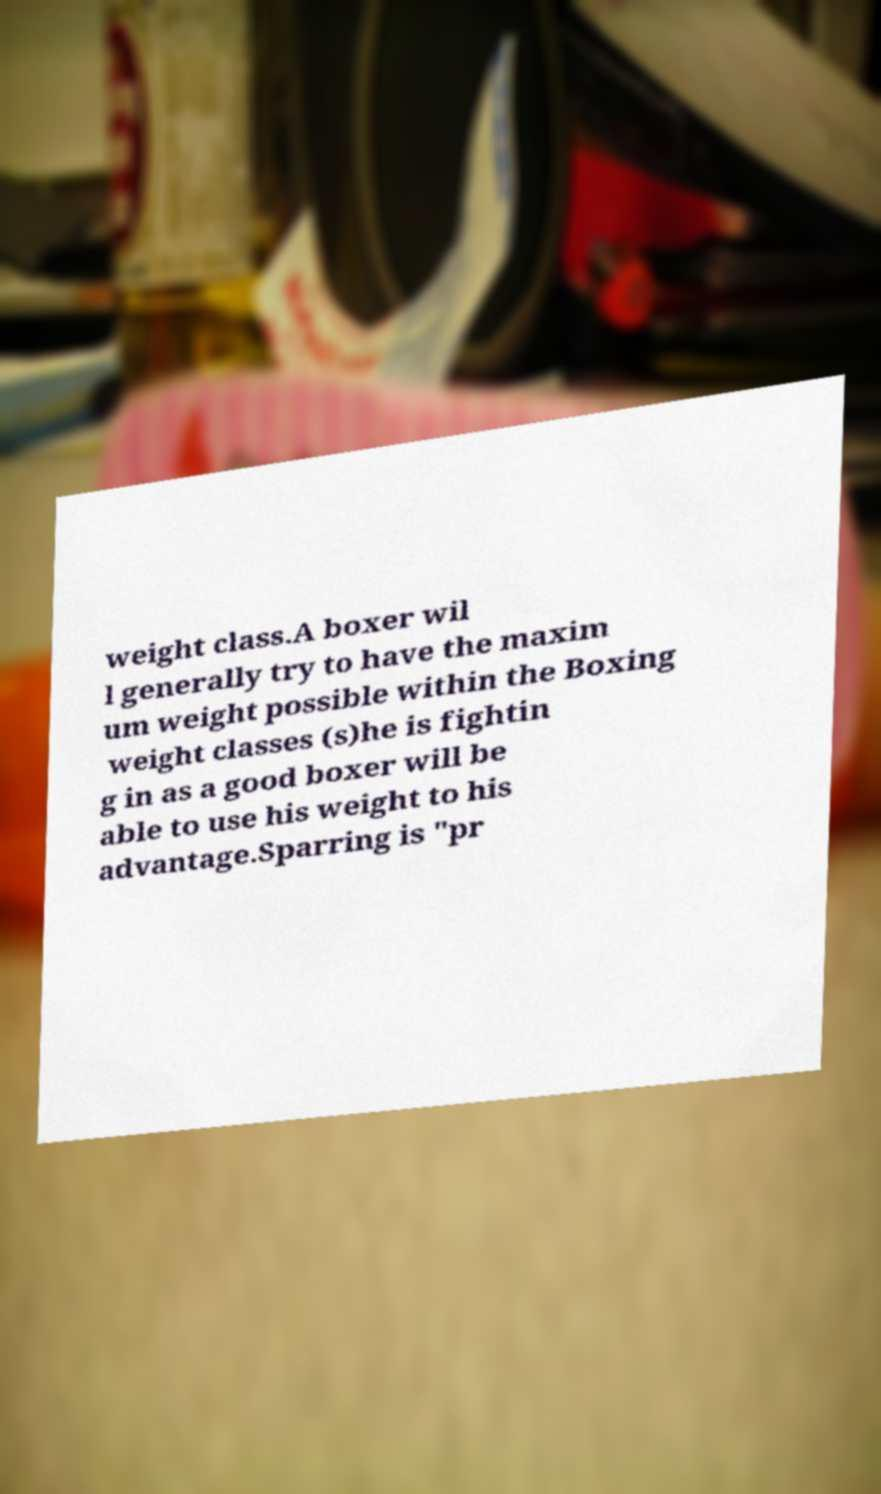For documentation purposes, I need the text within this image transcribed. Could you provide that? weight class.A boxer wil l generally try to have the maxim um weight possible within the Boxing weight classes (s)he is fightin g in as a good boxer will be able to use his weight to his advantage.Sparring is "pr 